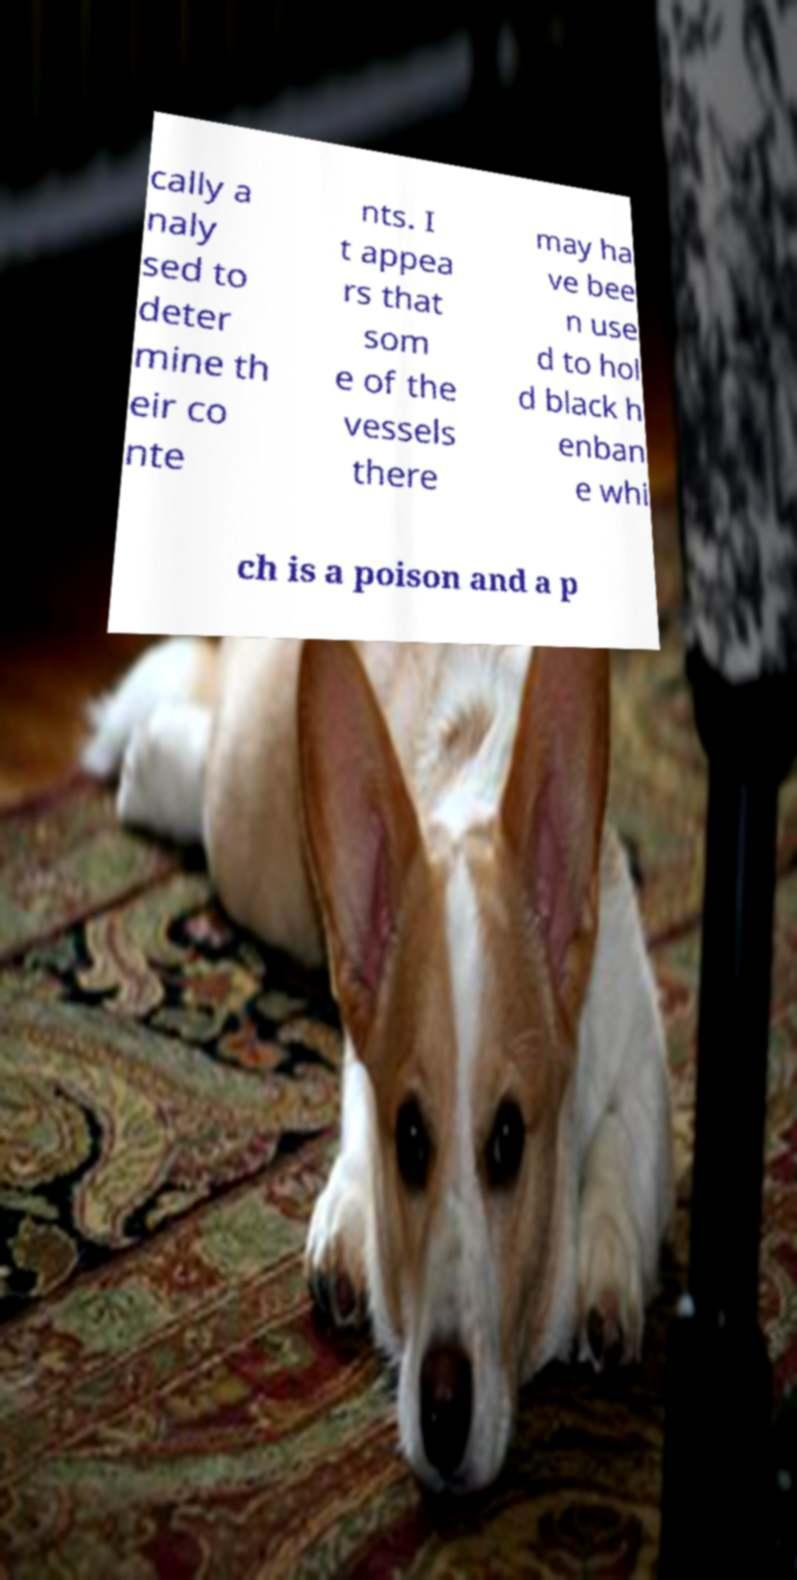Can you read and provide the text displayed in the image?This photo seems to have some interesting text. Can you extract and type it out for me? cally a naly sed to deter mine th eir co nte nts. I t appea rs that som e of the vessels there may ha ve bee n use d to hol d black h enban e whi ch is a poison and a p 